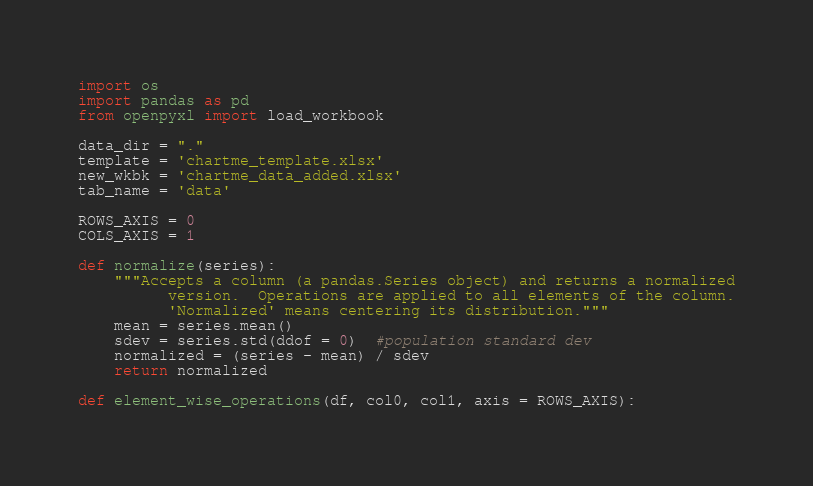Convert code to text. <code><loc_0><loc_0><loc_500><loc_500><_Python_>import os
import pandas as pd
from openpyxl import load_workbook

data_dir = "."
template = 'chartme_template.xlsx'
new_wkbk = 'chartme_data_added.xlsx'
tab_name = 'data'

ROWS_AXIS = 0
COLS_AXIS = 1

def normalize(series):
    """Accepts a column (a pandas.Series object) and returns a normalized
          version.  Operations are applied to all elements of the column.
          'Normalized' means centering its distribution."""
    mean = series.mean()
    sdev = series.std(ddof = 0)  #population standard dev
    normalized = (series - mean) / sdev
    return normalized

def element_wise_operations(df, col0, col1, axis = ROWS_AXIS):</code> 